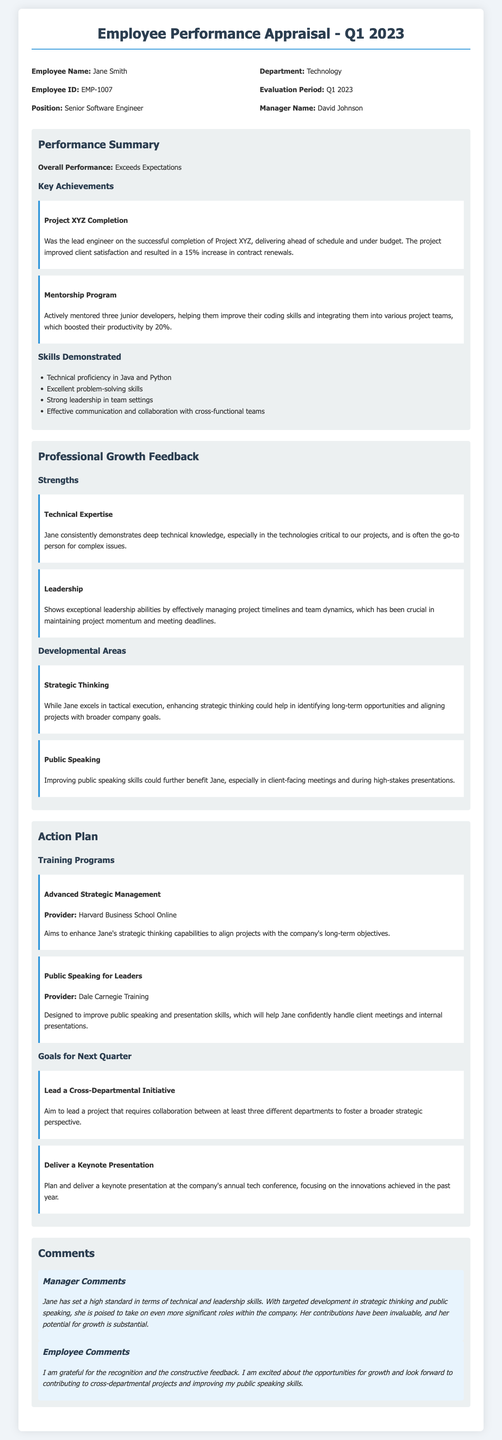What is the employee's name? The employee's name is listed at the top of the document under employee details.
Answer: Jane Smith What position does Jane Smith hold? The position is specified in the header information of the appraisal form.
Answer: Senior Software Engineer What was the overall performance rating? The overall performance is stated clearly in the performance summary section.
Answer: Exceeds Expectations What is one of Jane's key achievements? The key achievements are listed in the performance summary section, where specific projects are highlighted.
Answer: Project XYZ Completion What training program is suggested to improve public speaking skills? The training programs are outlined in the action plan section, specifically recommending training relevant to public speaking.
Answer: Public Speaking for Leaders Which two areas are identified for Jane's development? The developmental areas are clearly identified under the professional growth feedback section.
Answer: Strategic Thinking, Public Speaking Who is Jane's manager? The manager's name is provided in the header information of the appraisal form.
Answer: David Johnson What goal does Jane have for the next quarter? The goals for the next quarter are listed in the action plan section, outlining specific objectives for her upcoming performance.
Answer: Lead a Cross-Departmental Initiative What does the manager comment about Jane's contribution? The manager's comments contain evaluations of Jane's work and contributions, offering insight into her performance.
Answer: Invaluable 